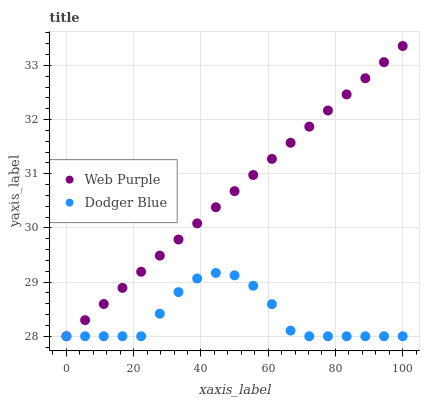Does Dodger Blue have the minimum area under the curve?
Answer yes or no. Yes. Does Web Purple have the maximum area under the curve?
Answer yes or no. Yes. Does Dodger Blue have the maximum area under the curve?
Answer yes or no. No. Is Web Purple the smoothest?
Answer yes or no. Yes. Is Dodger Blue the roughest?
Answer yes or no. Yes. Is Dodger Blue the smoothest?
Answer yes or no. No. Does Web Purple have the lowest value?
Answer yes or no. Yes. Does Web Purple have the highest value?
Answer yes or no. Yes. Does Dodger Blue have the highest value?
Answer yes or no. No. Does Dodger Blue intersect Web Purple?
Answer yes or no. Yes. Is Dodger Blue less than Web Purple?
Answer yes or no. No. Is Dodger Blue greater than Web Purple?
Answer yes or no. No. 